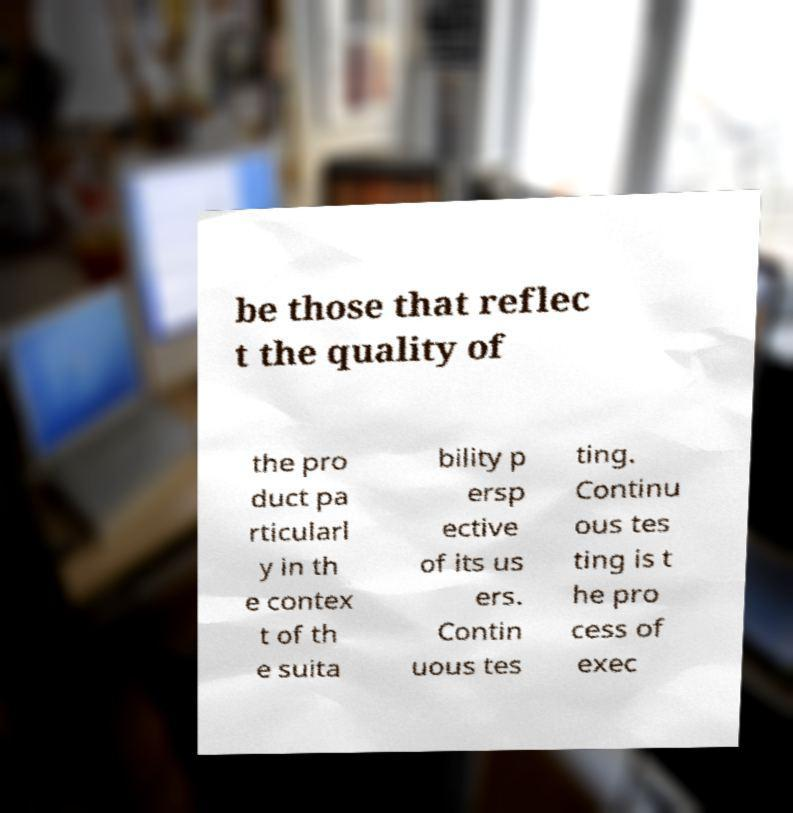For documentation purposes, I need the text within this image transcribed. Could you provide that? be those that reflec t the quality of the pro duct pa rticularl y in th e contex t of th e suita bility p ersp ective of its us ers. Contin uous tes ting. Continu ous tes ting is t he pro cess of exec 